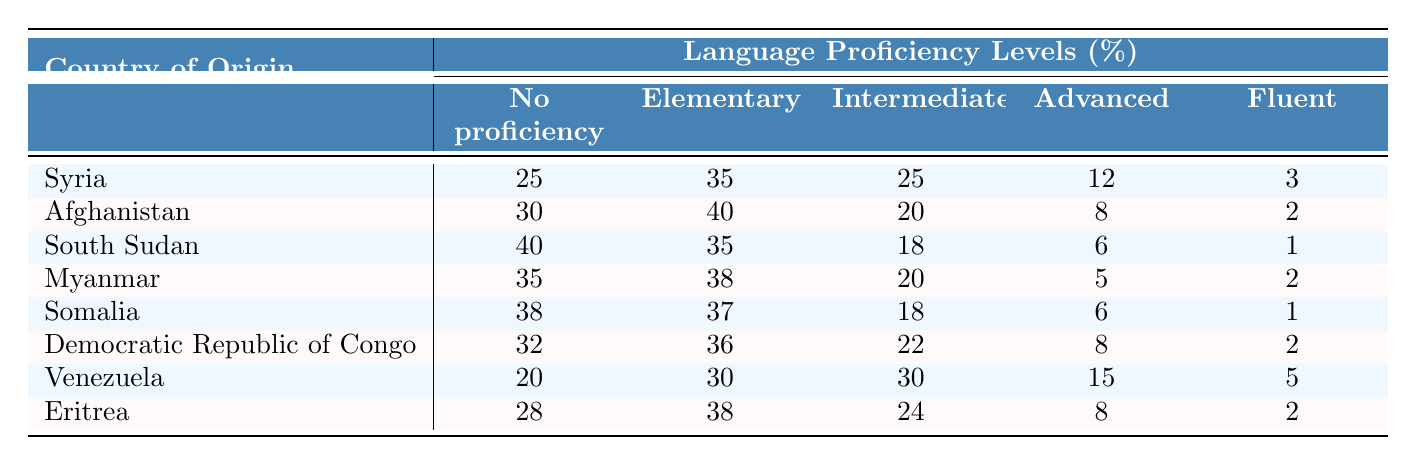What percentage of refugees from Syria have no language proficiency? The table indicates that 25% of refugees from Syria have no language proficiency.
Answer: 25% Which country has the highest percentage of refugees with no proficiency? By comparing the values, South Sudan has the highest percentage of 40%.
Answer: 40% What is the percentage of Afghans who are fluent in the language? According to the table, 2% of Afghan refugees are fluent.
Answer: 2% What is the total percentage of both intermediate and advanced language proficiency among refugees from Venezuela? The table shows 30% are intermediate and 15% are advanced, so the total is 30% + 15% = 45%.
Answer: 45% Which country has the most refugees with elementary language proficiency? Afghanistan has the highest elementary proficiency at 40%.
Answer: Afghanistan Is the statement "more than 30% of Eritrean refugees have elementary proficiency" true? The table indicates that 38% of Eritrean refugees have elementary proficiency, which confirms the statement is true.
Answer: True What is the average percentage of the "Fluent" proficiency level across all countries listed? To find the average, add up the fluent percentages (3 + 2 + 1 + 2 + 1 + 2 + 5 + 2 = 18) and divide by the number of countries (8), which gives an average of 18/8 = 2.25%.
Answer: 2.25% From the data, which two countries have the same percentage of intermediate proficiency? Myanmar and Venezuela both have 30% intermediate proficiency.
Answer: Myanmar and Venezuela How many more Afghans than South Sudanese have elementary proficiency? There are 40% of Afghans with elementary proficiency and 35% of South Sudanese, so the difference is 40% - 35% = 5%.
Answer: 5% What is the sum of all percentages of refugees in South Sudan who have any form of language proficiency? South Sudan has 40% (no proficiency) + 35% (elementary) + 18% (intermediate) + 6% (advanced) + 1% (fluent) = 100%.
Answer: 100% 